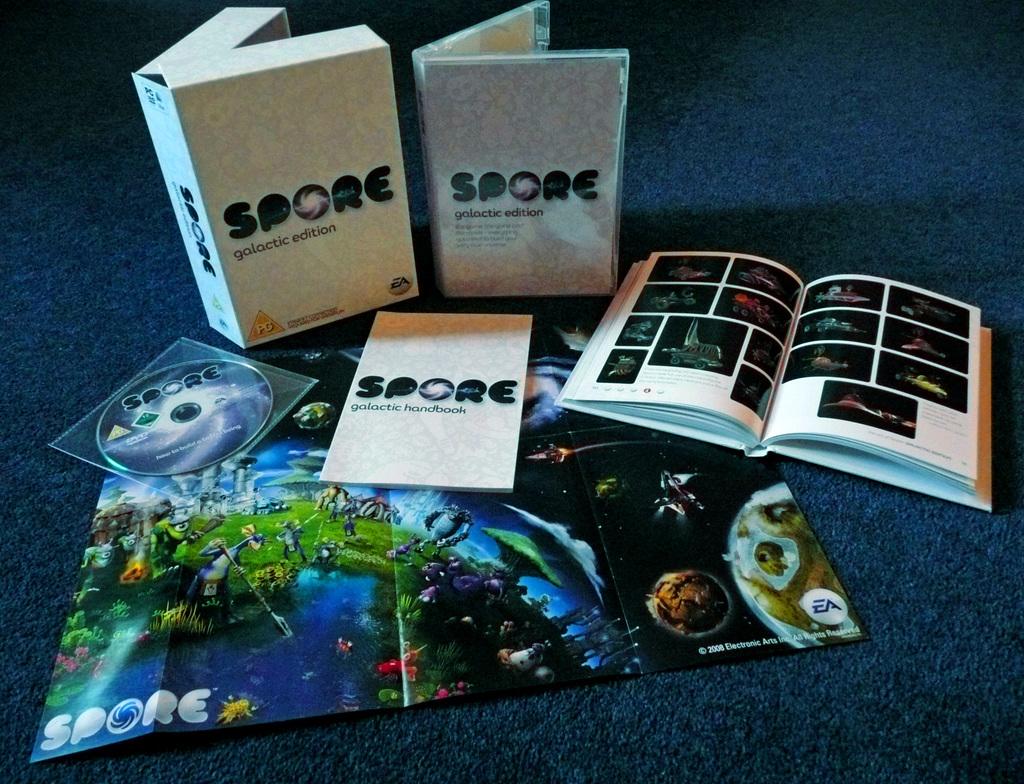What is the name of the software maker?
Your response must be concise. Ea. What is the name of this game?
Provide a succinct answer. Spore. 